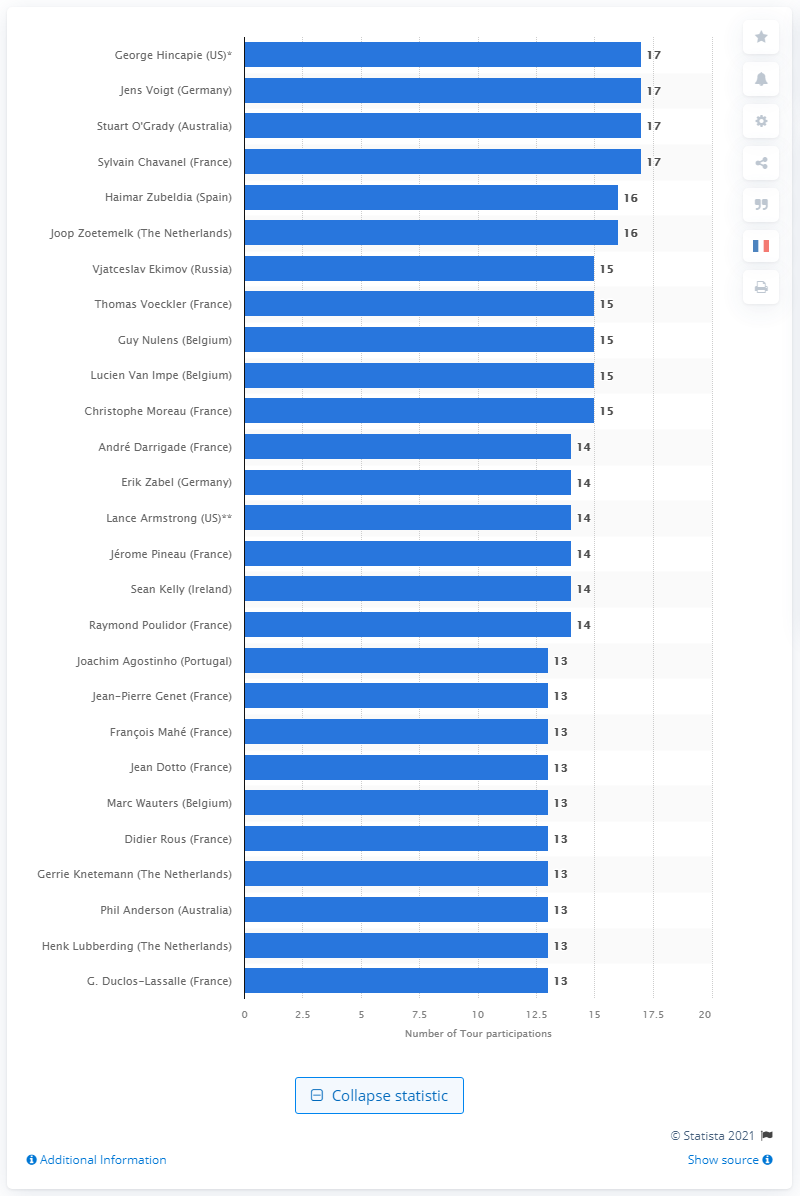Identify some key points in this picture. George Hincapie has participated in the Tour de France 17 times. 